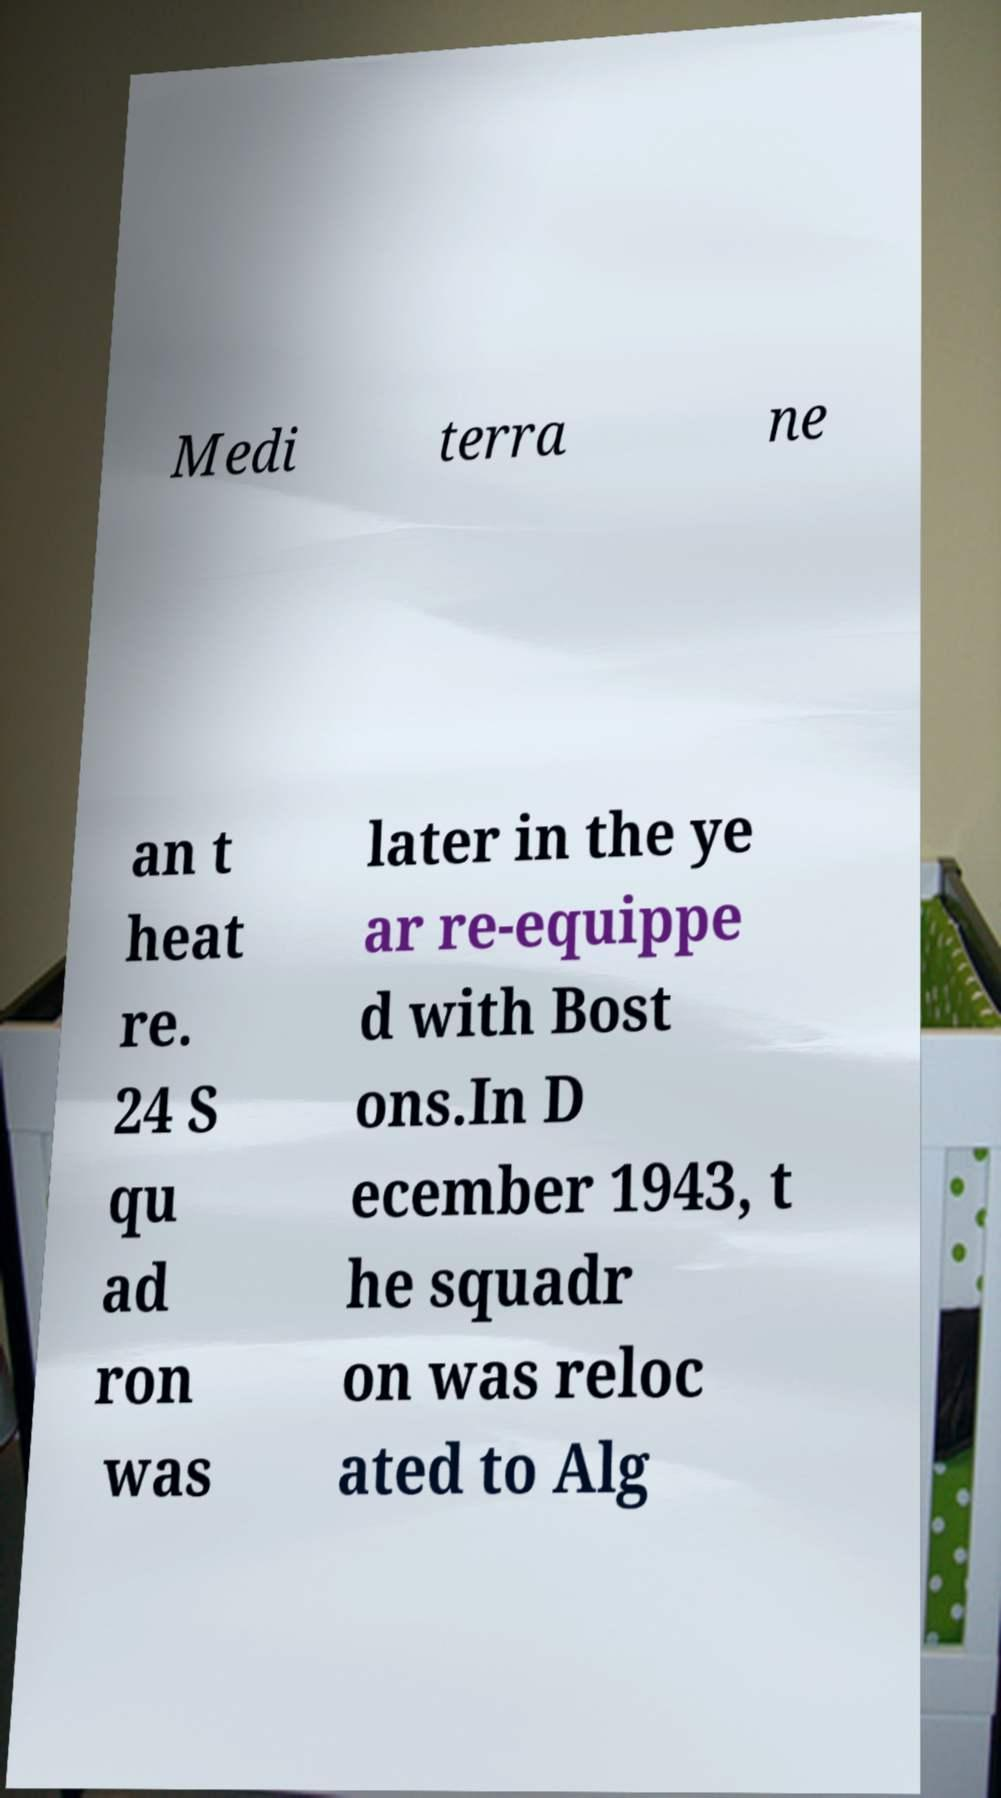Can you read and provide the text displayed in the image?This photo seems to have some interesting text. Can you extract and type it out for me? Medi terra ne an t heat re. 24 S qu ad ron was later in the ye ar re-equippe d with Bost ons.In D ecember 1943, t he squadr on was reloc ated to Alg 